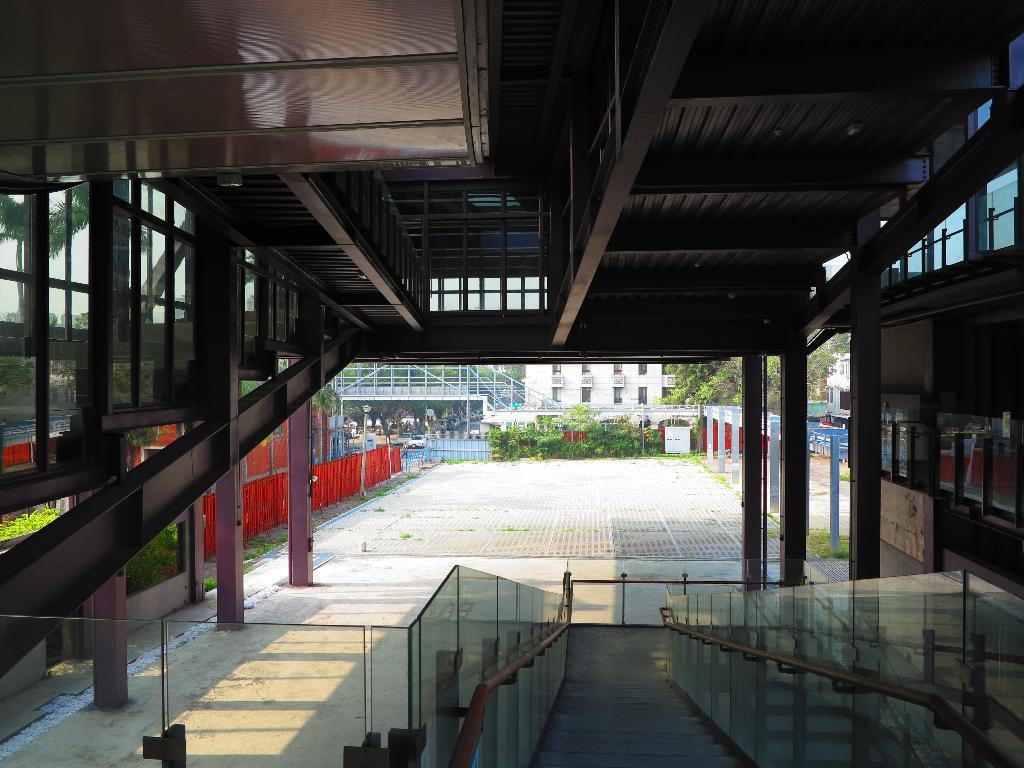What type of structure is visible in the image? There is a building in the image. What is located at the bottom of the image? There is a glass railing at the bottom of the image. What can be seen in the background of the image? There are plants and trees in the background of the image. What type of vest is being worn by the lettuce in the image? There is no lettuce or vest present in the image. 